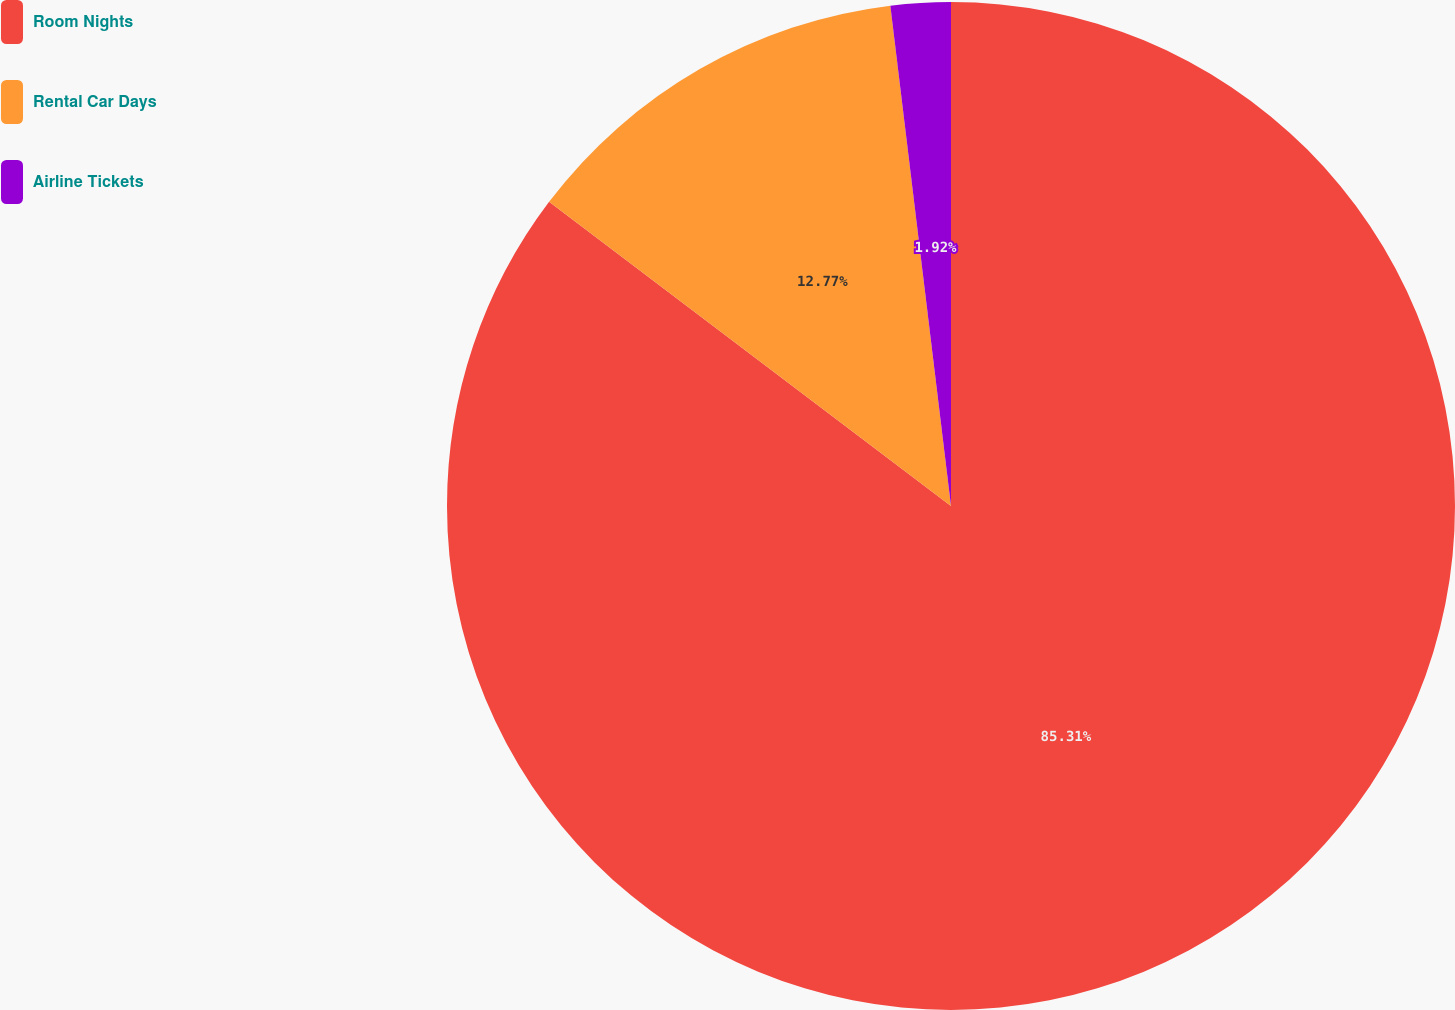<chart> <loc_0><loc_0><loc_500><loc_500><pie_chart><fcel>Room Nights<fcel>Rental Car Days<fcel>Airline Tickets<nl><fcel>85.31%<fcel>12.77%<fcel>1.92%<nl></chart> 